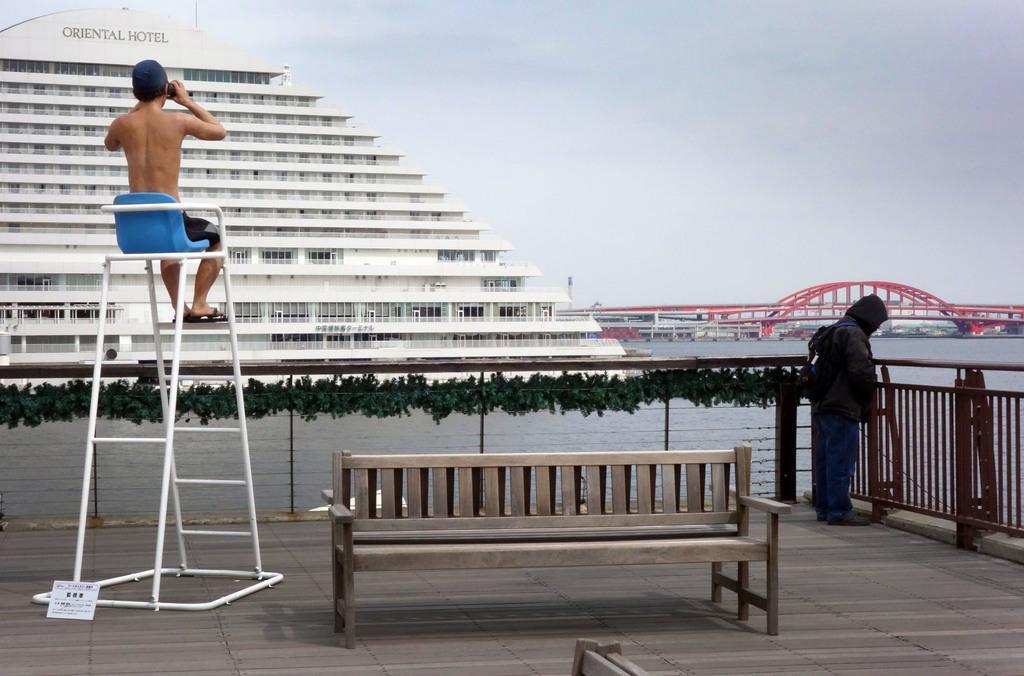In one or two sentences, can you explain what this image depicts? In this picture we can see a person sitting on the chair. There is a paper on the path. We can see another person on the path. There is a building and a bridge. We can see some fencing on the right side. 